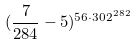Convert formula to latex. <formula><loc_0><loc_0><loc_500><loc_500>( \frac { 7 } { 2 8 4 } - 5 ) ^ { 5 6 \cdot 3 0 2 ^ { 2 8 2 } }</formula> 